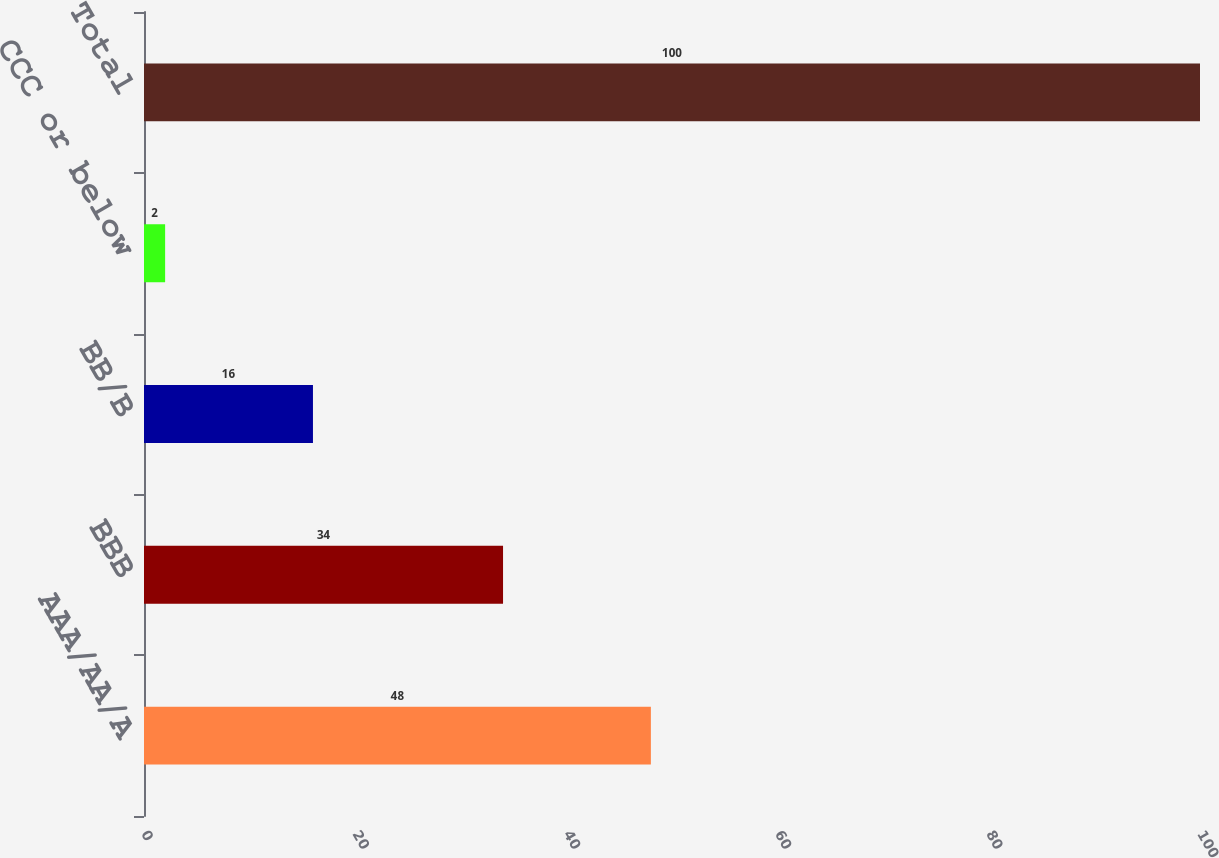<chart> <loc_0><loc_0><loc_500><loc_500><bar_chart><fcel>AAA/AA/A<fcel>BBB<fcel>BB/B<fcel>CCC or below<fcel>Total<nl><fcel>48<fcel>34<fcel>16<fcel>2<fcel>100<nl></chart> 